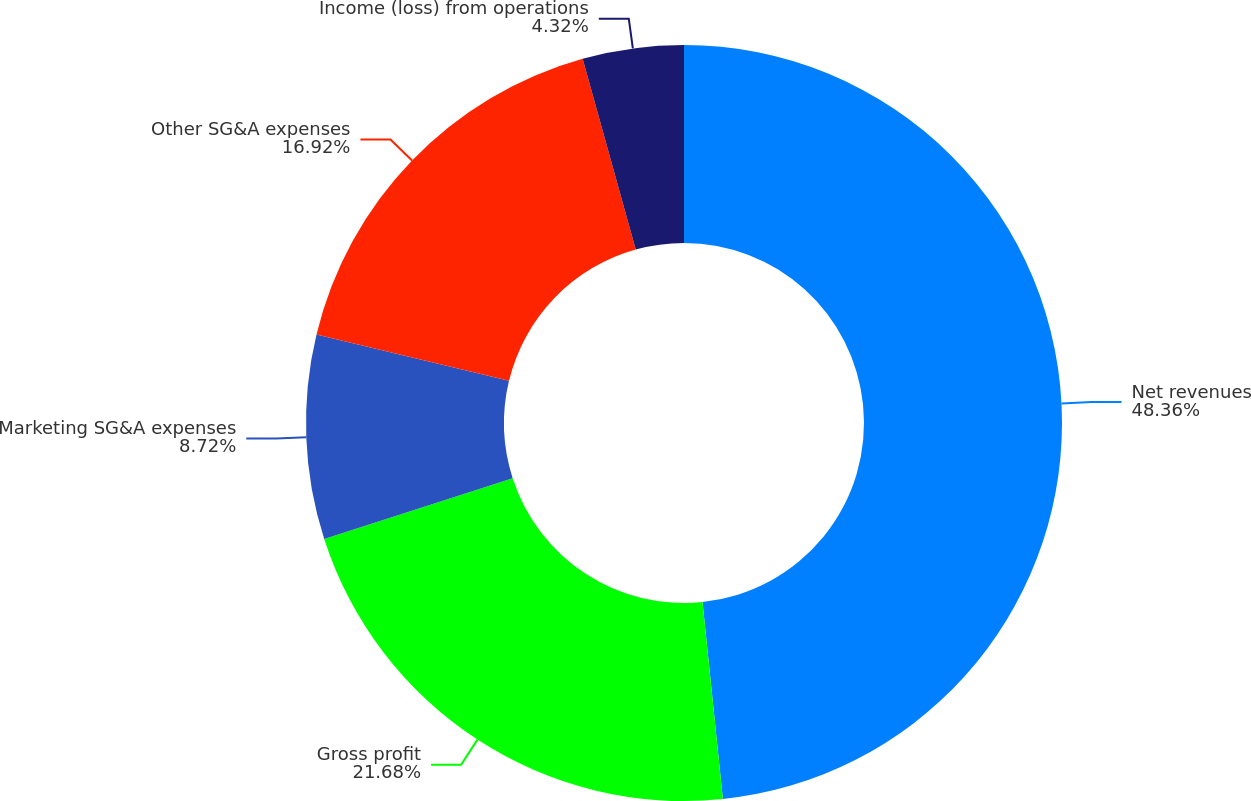<chart> <loc_0><loc_0><loc_500><loc_500><pie_chart><fcel>Net revenues<fcel>Gross profit<fcel>Marketing SG&A expenses<fcel>Other SG&A expenses<fcel>Income (loss) from operations<nl><fcel>48.36%<fcel>21.68%<fcel>8.72%<fcel>16.92%<fcel>4.32%<nl></chart> 